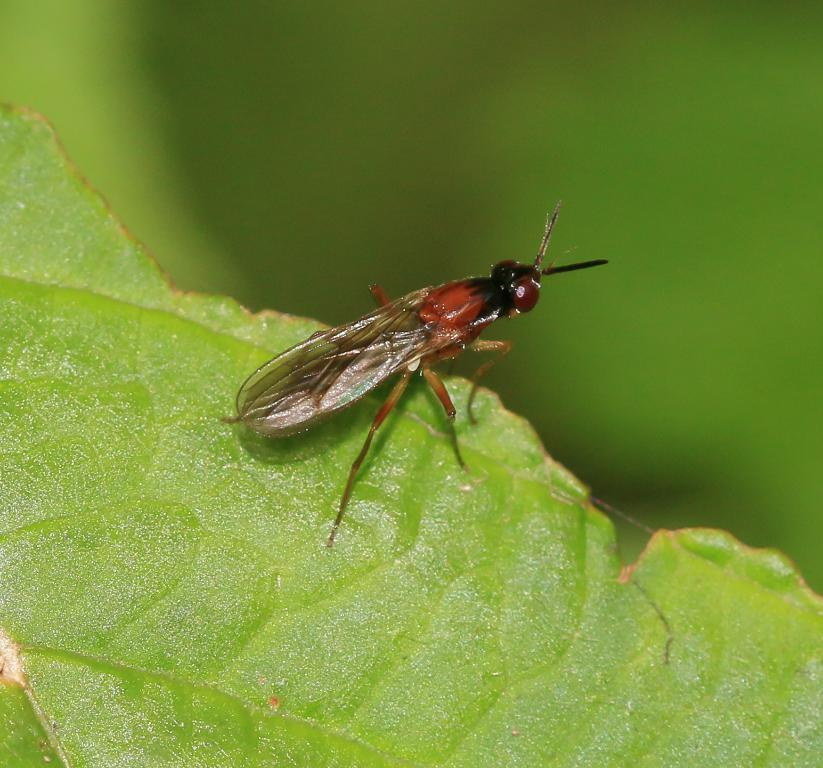What type of creature is present in the image? There is an insect in the image. What feature does the insect have? The insect has wings. What is the insect standing on? The insect is standing on a green leaf. How would you describe the background of the image? The background of the image is blurred. What type of linen is being used to wrap the parcel in the image? There is no linen or parcel present in the image; it features an insect standing on a green leaf. 